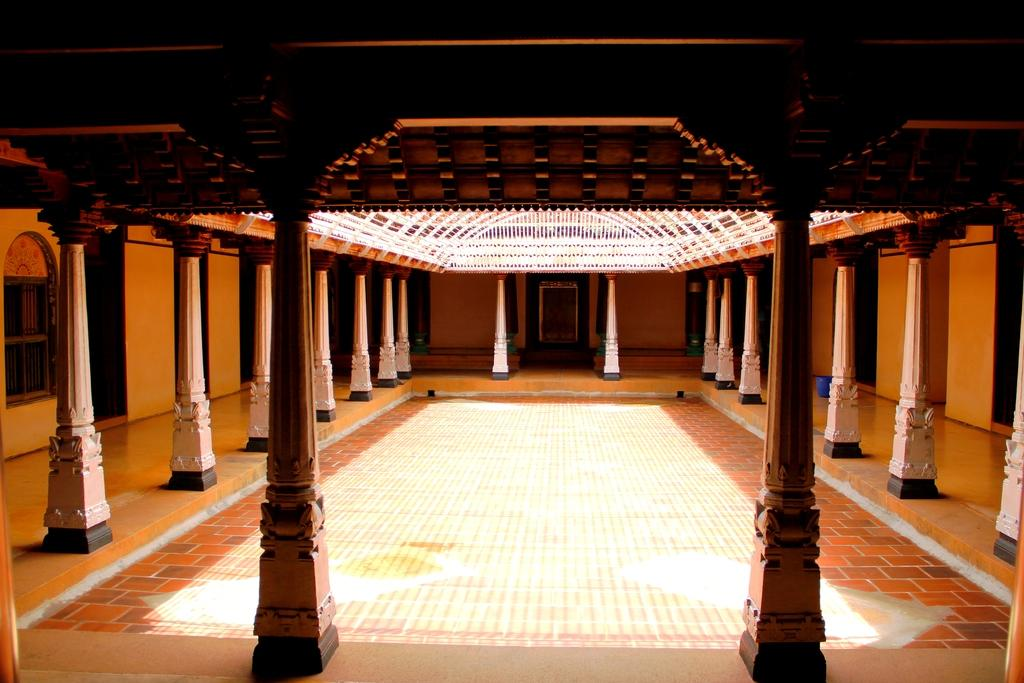What is the location of the person taking the image? The image is taken from inside a building. What architectural features can be seen in the image? There are pillars, a window, walls, and a door visible in the image. What is the condition of the roof in the image? There is an open roof visible at the top of the image. What type of noise can be heard coming from the crate in the image? There is no crate present in the image, so it is not possible to determine what noise might be heard. 